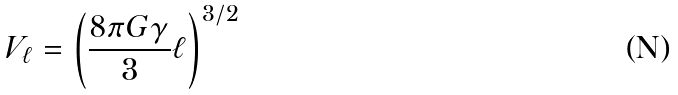Convert formula to latex. <formula><loc_0><loc_0><loc_500><loc_500>V _ { \ell } = \left ( \frac { 8 \pi G \gamma } { 3 } \ell \right ) ^ { 3 / 2 }</formula> 